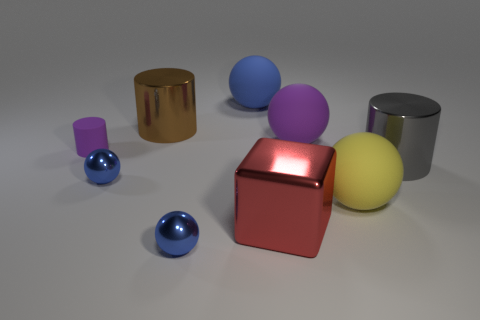Subtract all blue balls. How many balls are left? 2 Subtract all brown cylinders. How many blue spheres are left? 3 Subtract all purple spheres. How many spheres are left? 4 Subtract 2 balls. How many balls are left? 3 Add 1 small yellow matte objects. How many objects exist? 10 Subtract all cyan cylinders. Subtract all gray cubes. How many cylinders are left? 3 Subtract all cubes. How many objects are left? 8 Add 9 large purple rubber balls. How many large purple rubber balls are left? 10 Add 6 purple shiny spheres. How many purple shiny spheres exist? 6 Subtract 0 red balls. How many objects are left? 9 